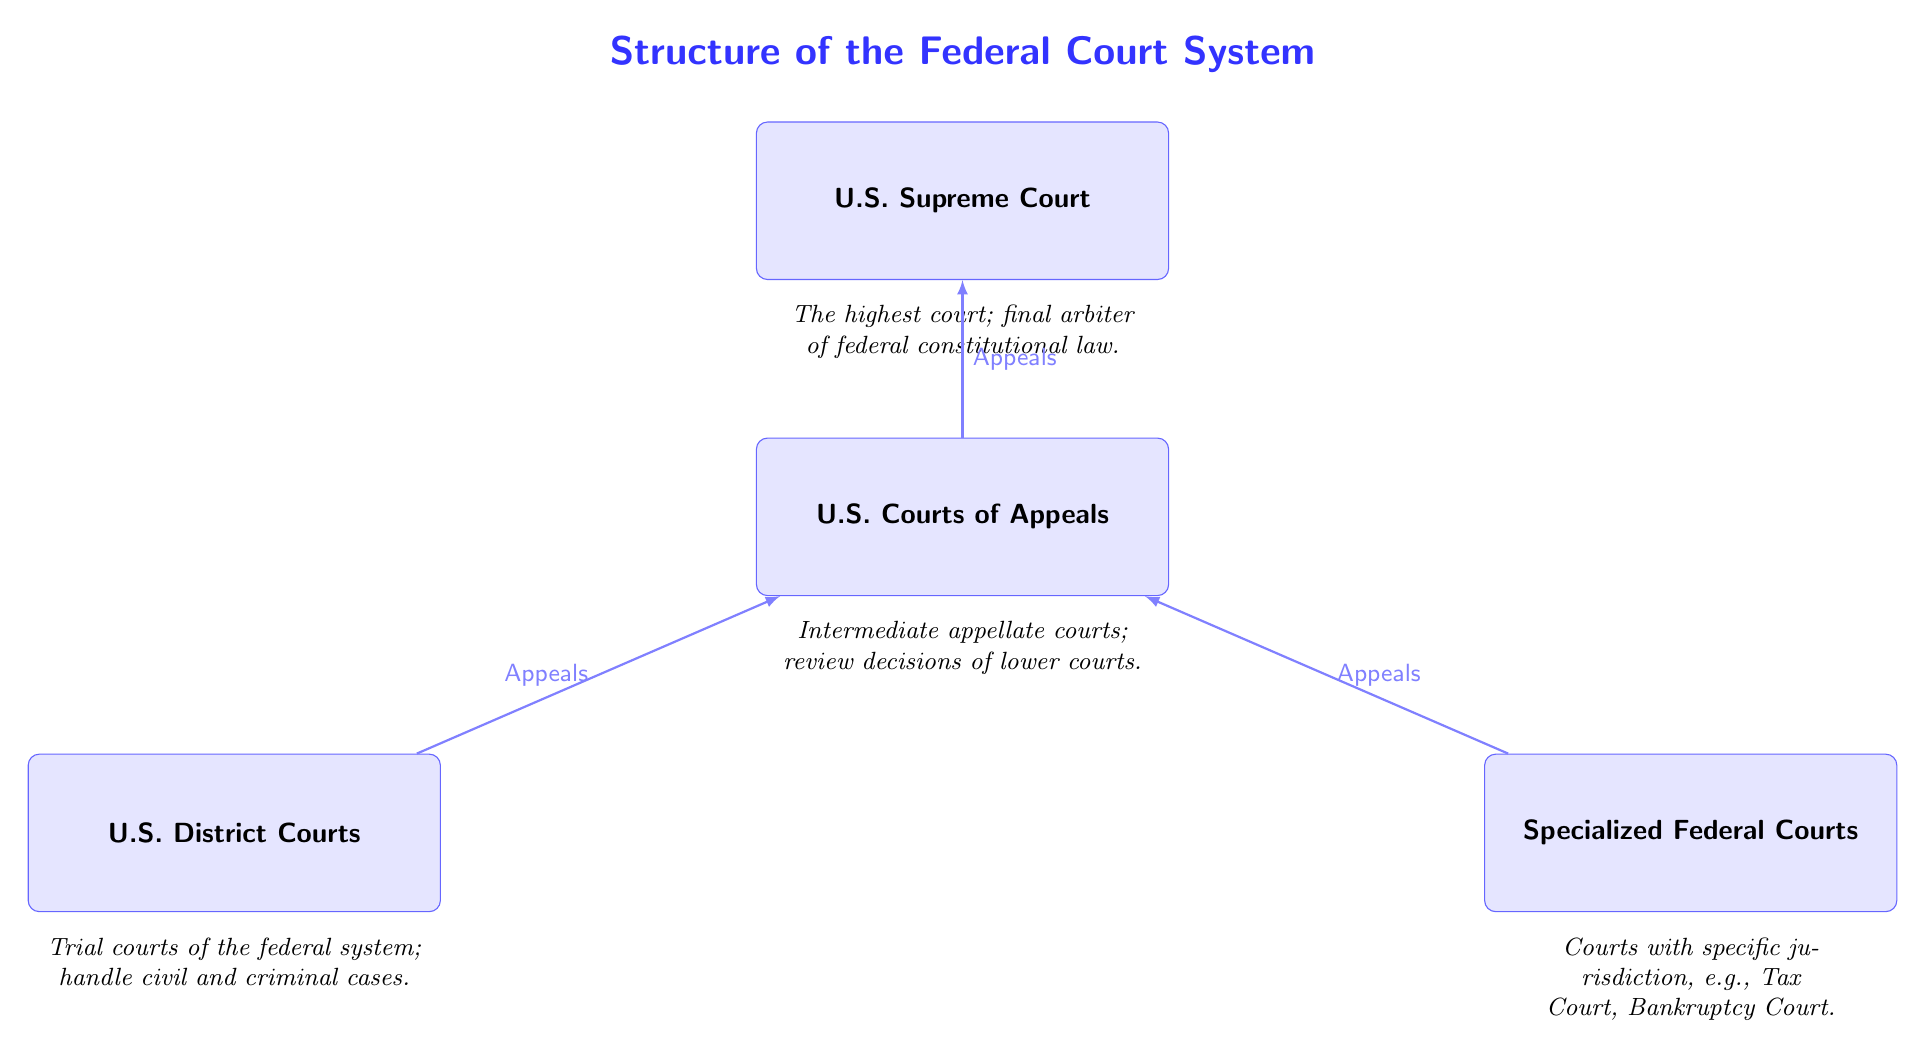What is the highest court in the federal system? The highest court is labeled as the U.S. Supreme Court, which is at the top of the diagram.
Answer: U.S. Supreme Court How many types of courts are listed in the diagram? The diagram showcases four types of courts: U.S. Supreme Court, U.S. Courts of Appeals, U.S. District Courts, and Specialized Federal Courts.
Answer: Four What do the U.S. Courts of Appeals review? According to the description next to U.S. Courts of Appeals, they review decisions made by the lower courts.
Answer: Decisions of lower courts What type of cases do U.S. District Courts handle? The description indicates that U.S. District Courts handle both civil and criminal cases, which defines their function.
Answer: Civil and criminal cases Which courts are directly below the U.S. Courts of Appeals? The diagram shows that U.S. District Courts and Specialized Federal Courts are positioned directly below the U.S. Courts of Appeals in the hierarchy.
Answer: U.S. District Courts and Specialized Federal Courts How do cases progress from U.S. District Courts to the U.S. Supreme Court? The flow indicates that cases from U.S. District Courts appeal to U.S. Courts of Appeals, and from there, they can further appeal to the U.S. Supreme Court. This creates a pathway through the diagram.
Answer: Through U.S. Courts of Appeals What is the purpose of Specialized Federal Courts as shown in the diagram? The description clearly states that Specialized Federal Courts have specific jurisdiction, which implies that they handle particular types of cases such as Tax Court and Bankruptcy Court.
Answer: Specific jurisdiction What is the function of the U.S. Supreme Court? The U.S. Supreme Court is described as the final arbiter of federal constitutional law, highlighting its significant judicial authority.
Answer: Final arbiter of federal constitutional law What connects the U.S. District Courts to the U.S. Courts of Appeals? The diagram illustrates an arrow labeled "Appeals" between U.S. District Courts and U.S. Courts of Appeals, indicating the direction of case progression.
Answer: Appeals 